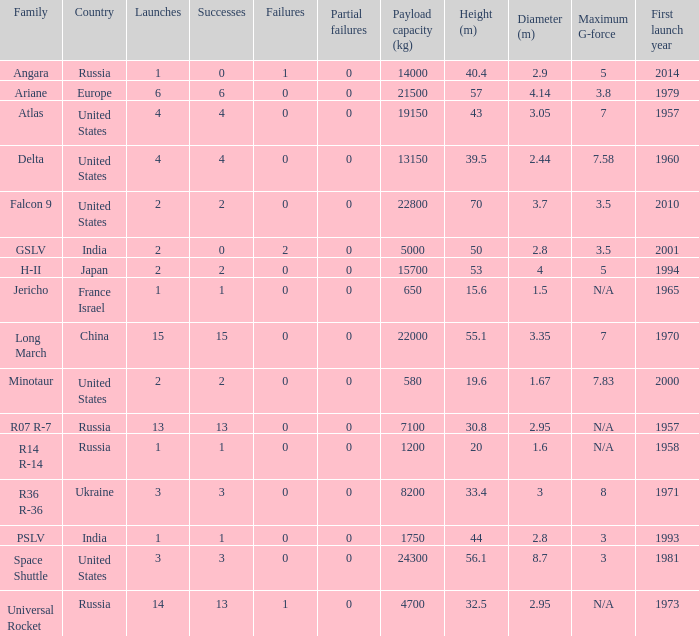What is the number of failure for the country of Russia, and a Family of r14 r-14, and a Partial failures smaller than 0? 0.0. 